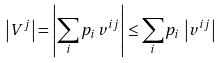<formula> <loc_0><loc_0><loc_500><loc_500>\left | V ^ { j } \right | = \left | \sum _ { i } p _ { i } \, v ^ { i j } \right | \leq \sum _ { i } p _ { i } \, \left | v ^ { i j } \right |</formula> 